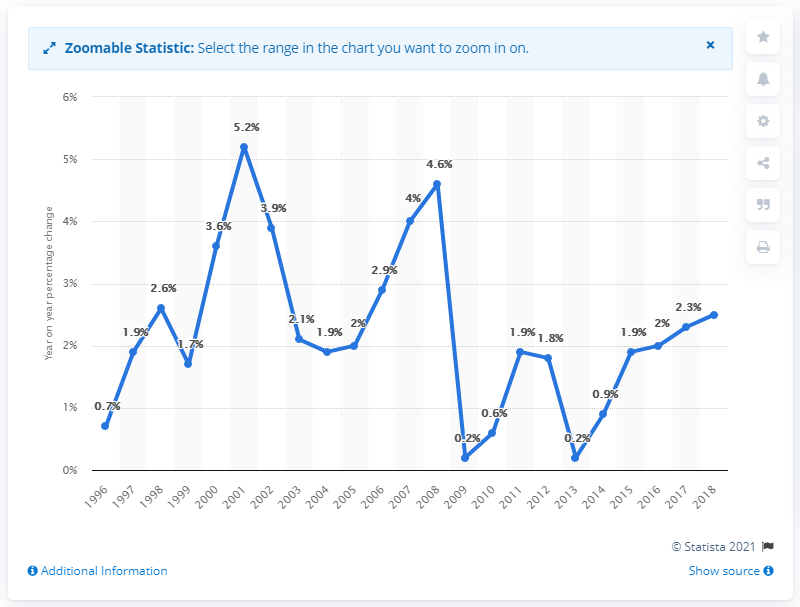List a handful of essential elements in this visual. The expected increase in real estate prices in 2017 is projected to be 2.6%. In 2016, the average selling price of houses was higher than it was in 2013. The construction costs increased by 2.6% in 2018 compared to the previous year. 